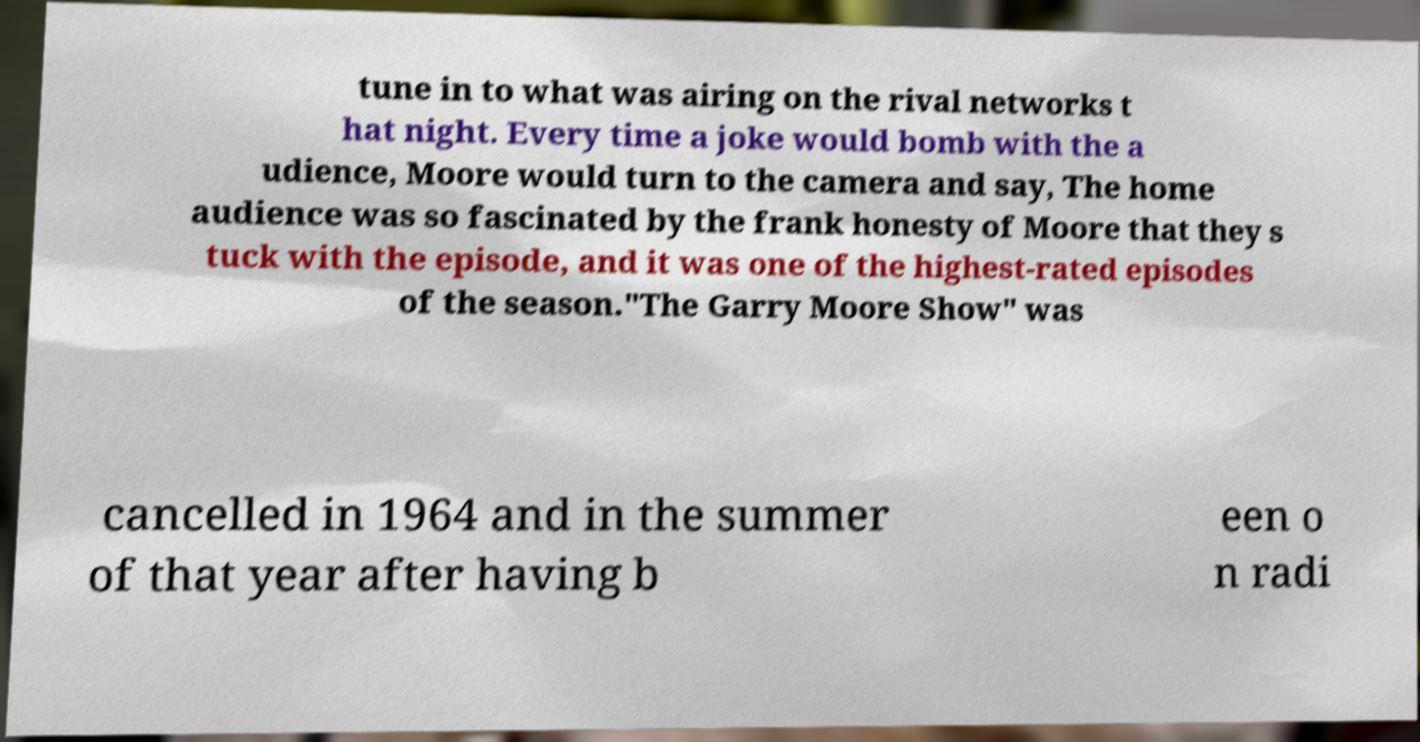Could you assist in decoding the text presented in this image and type it out clearly? tune in to what was airing on the rival networks t hat night. Every time a joke would bomb with the a udience, Moore would turn to the camera and say, The home audience was so fascinated by the frank honesty of Moore that they s tuck with the episode, and it was one of the highest-rated episodes of the season."The Garry Moore Show" was cancelled in 1964 and in the summer of that year after having b een o n radi 